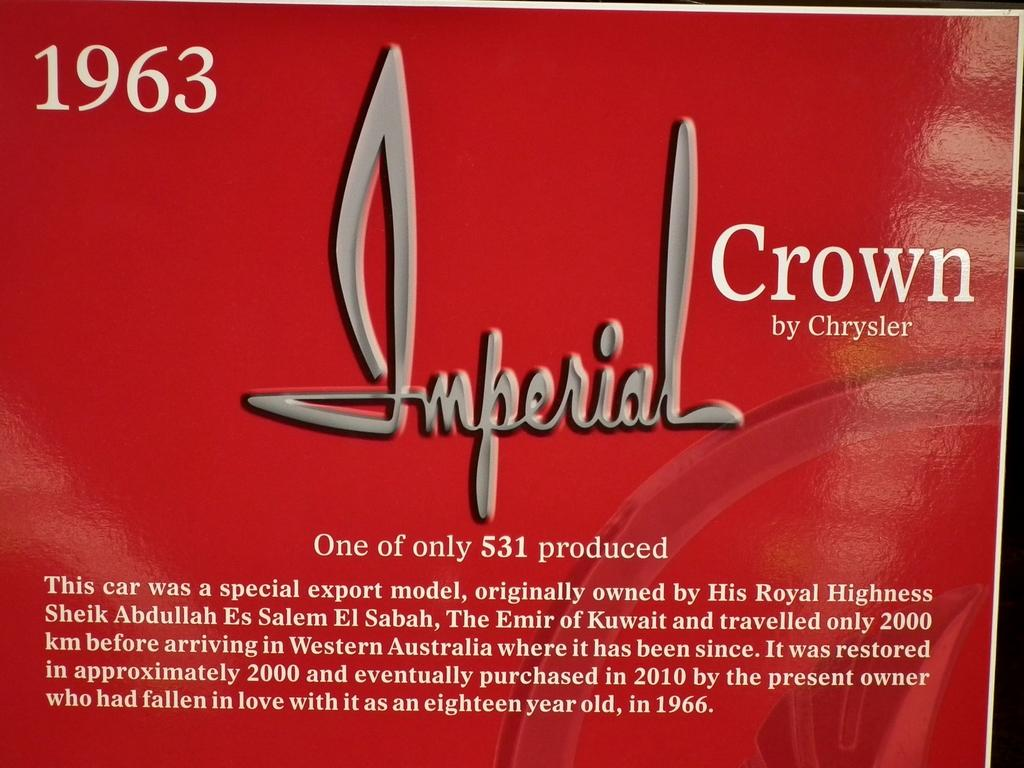<image>
Summarize the visual content of the image. a poster for Imperial Crown by Chrysler in 1963 